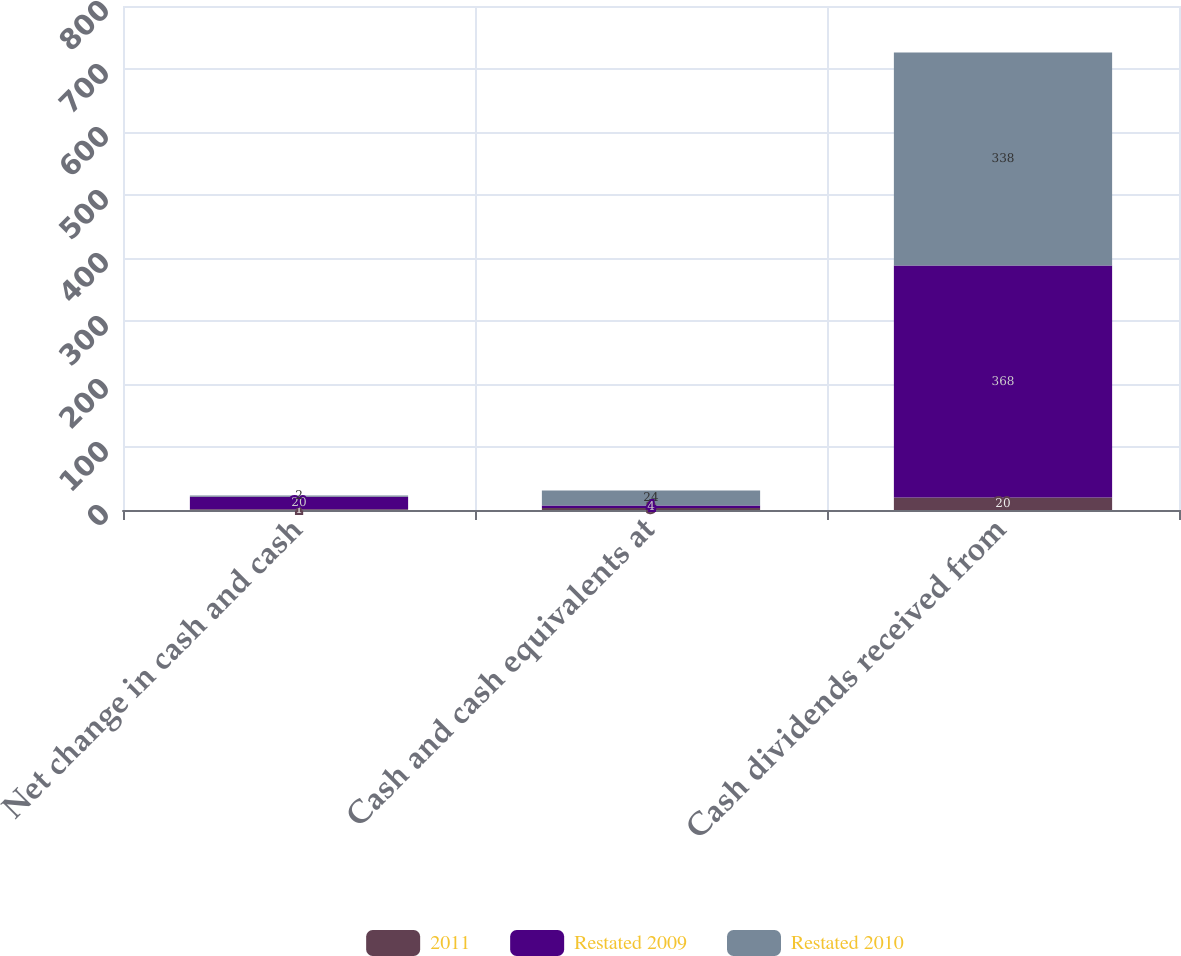<chart> <loc_0><loc_0><loc_500><loc_500><stacked_bar_chart><ecel><fcel>Net change in cash and cash<fcel>Cash and cash equivalents at<fcel>Cash dividends received from<nl><fcel>2011<fcel>1<fcel>3<fcel>20<nl><fcel>Restated 2009<fcel>20<fcel>4<fcel>368<nl><fcel>Restated 2010<fcel>2<fcel>24<fcel>338<nl></chart> 